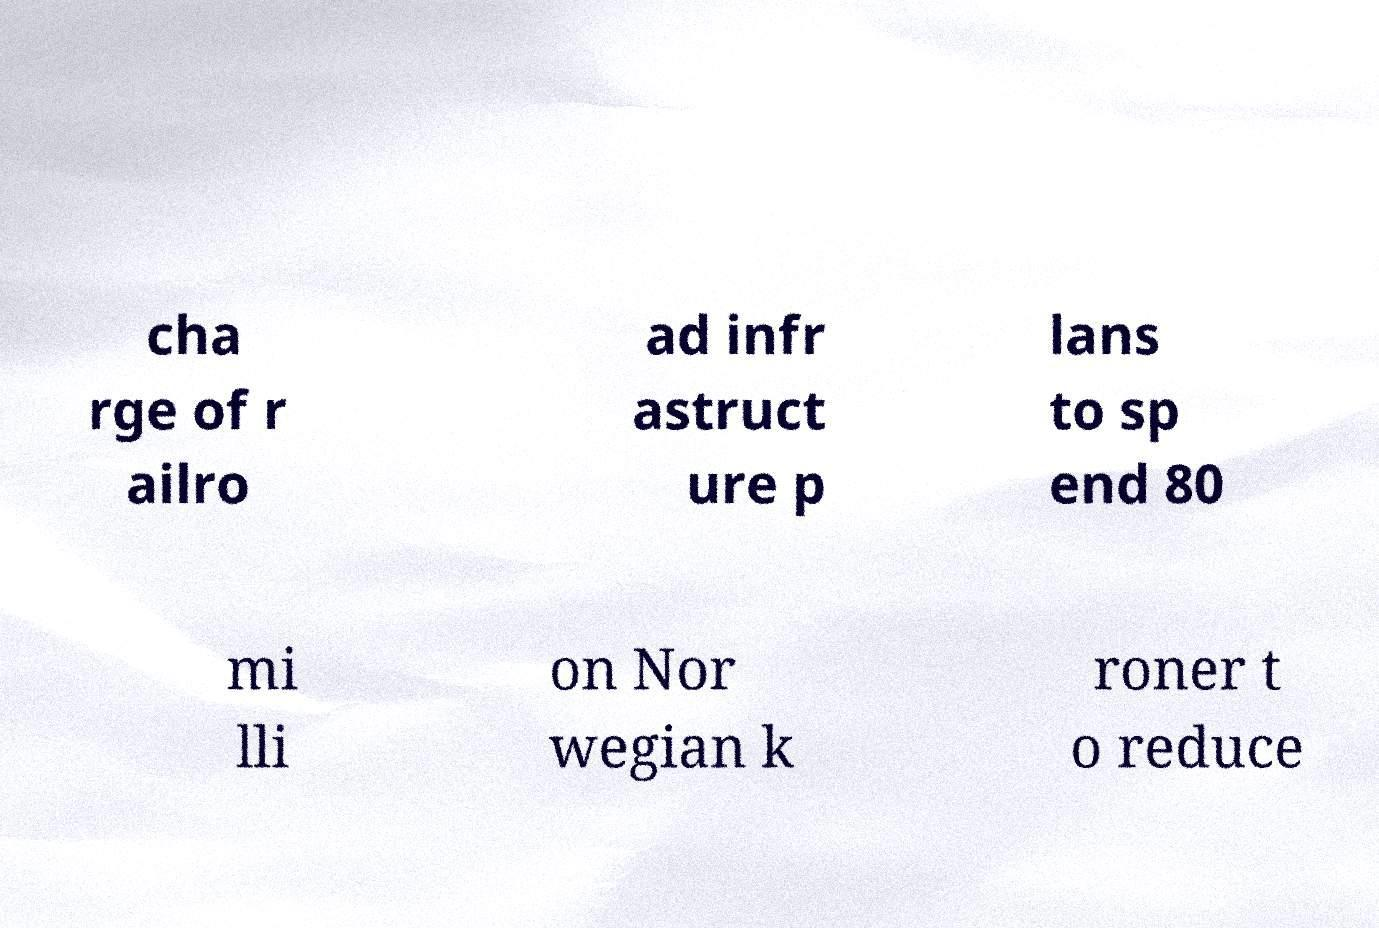There's text embedded in this image that I need extracted. Can you transcribe it verbatim? cha rge of r ailro ad infr astruct ure p lans to sp end 80 mi lli on Nor wegian k roner t o reduce 